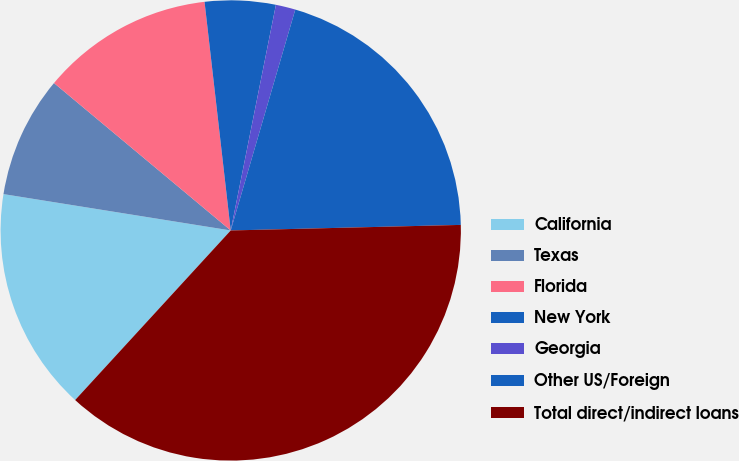<chart> <loc_0><loc_0><loc_500><loc_500><pie_chart><fcel>California<fcel>Texas<fcel>Florida<fcel>New York<fcel>Georgia<fcel>Other US/Foreign<fcel>Total direct/indirect loans<nl><fcel>15.71%<fcel>8.54%<fcel>12.12%<fcel>4.96%<fcel>1.38%<fcel>20.09%<fcel>37.2%<nl></chart> 